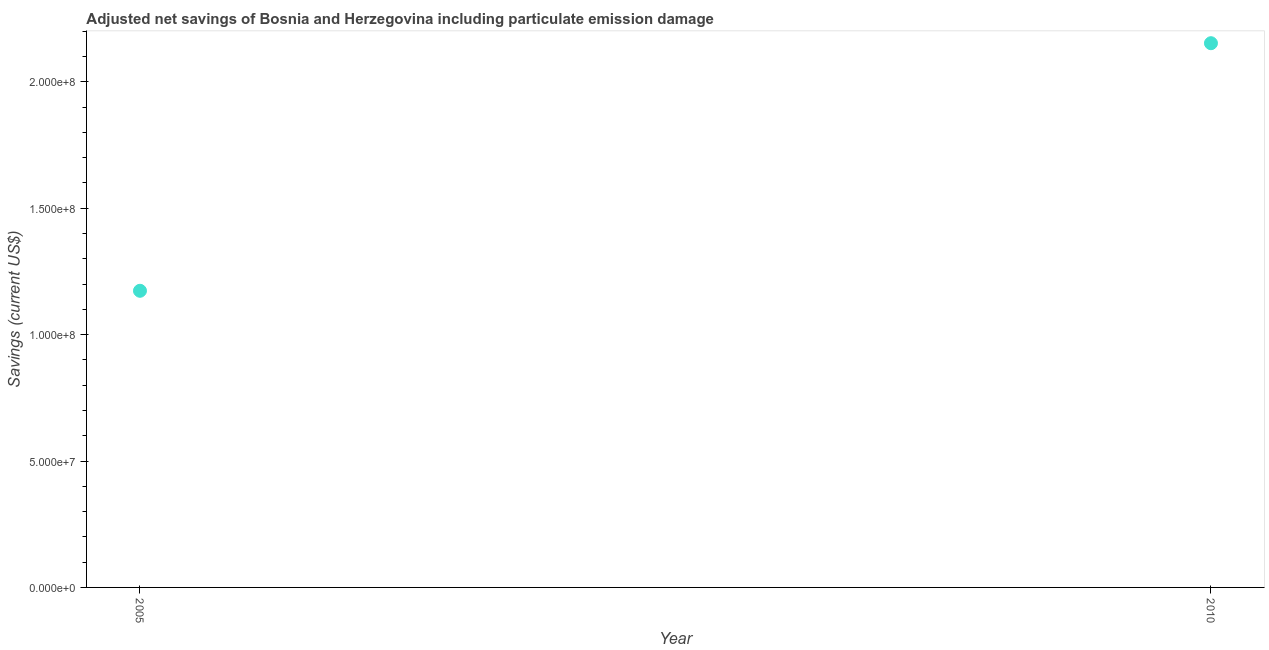What is the adjusted net savings in 2010?
Provide a short and direct response. 2.15e+08. Across all years, what is the maximum adjusted net savings?
Keep it short and to the point. 2.15e+08. Across all years, what is the minimum adjusted net savings?
Make the answer very short. 1.17e+08. In which year was the adjusted net savings maximum?
Provide a succinct answer. 2010. What is the sum of the adjusted net savings?
Offer a terse response. 3.33e+08. What is the difference between the adjusted net savings in 2005 and 2010?
Your answer should be very brief. -9.79e+07. What is the average adjusted net savings per year?
Your response must be concise. 1.66e+08. What is the median adjusted net savings?
Your answer should be very brief. 1.66e+08. What is the ratio of the adjusted net savings in 2005 to that in 2010?
Offer a terse response. 0.55. Does the adjusted net savings monotonically increase over the years?
Ensure brevity in your answer.  Yes. Does the graph contain any zero values?
Provide a succinct answer. No. Does the graph contain grids?
Make the answer very short. No. What is the title of the graph?
Your answer should be compact. Adjusted net savings of Bosnia and Herzegovina including particulate emission damage. What is the label or title of the Y-axis?
Your answer should be very brief. Savings (current US$). What is the Savings (current US$) in 2005?
Offer a terse response. 1.17e+08. What is the Savings (current US$) in 2010?
Ensure brevity in your answer.  2.15e+08. What is the difference between the Savings (current US$) in 2005 and 2010?
Ensure brevity in your answer.  -9.79e+07. What is the ratio of the Savings (current US$) in 2005 to that in 2010?
Offer a terse response. 0.55. 